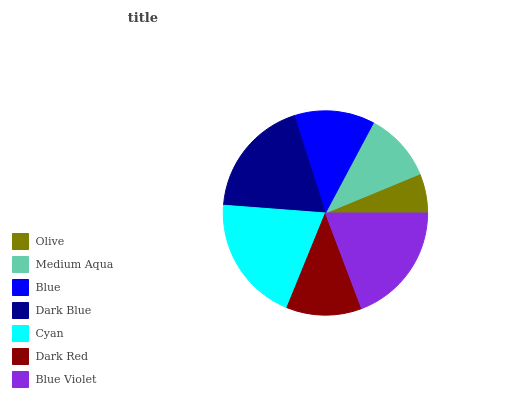Is Olive the minimum?
Answer yes or no. Yes. Is Cyan the maximum?
Answer yes or no. Yes. Is Medium Aqua the minimum?
Answer yes or no. No. Is Medium Aqua the maximum?
Answer yes or no. No. Is Medium Aqua greater than Olive?
Answer yes or no. Yes. Is Olive less than Medium Aqua?
Answer yes or no. Yes. Is Olive greater than Medium Aqua?
Answer yes or no. No. Is Medium Aqua less than Olive?
Answer yes or no. No. Is Blue the high median?
Answer yes or no. Yes. Is Blue the low median?
Answer yes or no. Yes. Is Cyan the high median?
Answer yes or no. No. Is Blue Violet the low median?
Answer yes or no. No. 